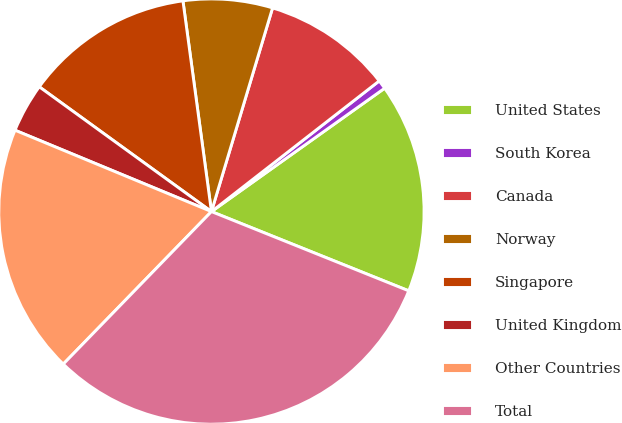Convert chart to OTSL. <chart><loc_0><loc_0><loc_500><loc_500><pie_chart><fcel>United States<fcel>South Korea<fcel>Canada<fcel>Norway<fcel>Singapore<fcel>United Kingdom<fcel>Other Countries<fcel>Total<nl><fcel>15.93%<fcel>0.68%<fcel>9.83%<fcel>6.78%<fcel>12.88%<fcel>3.73%<fcel>18.98%<fcel>31.19%<nl></chart> 